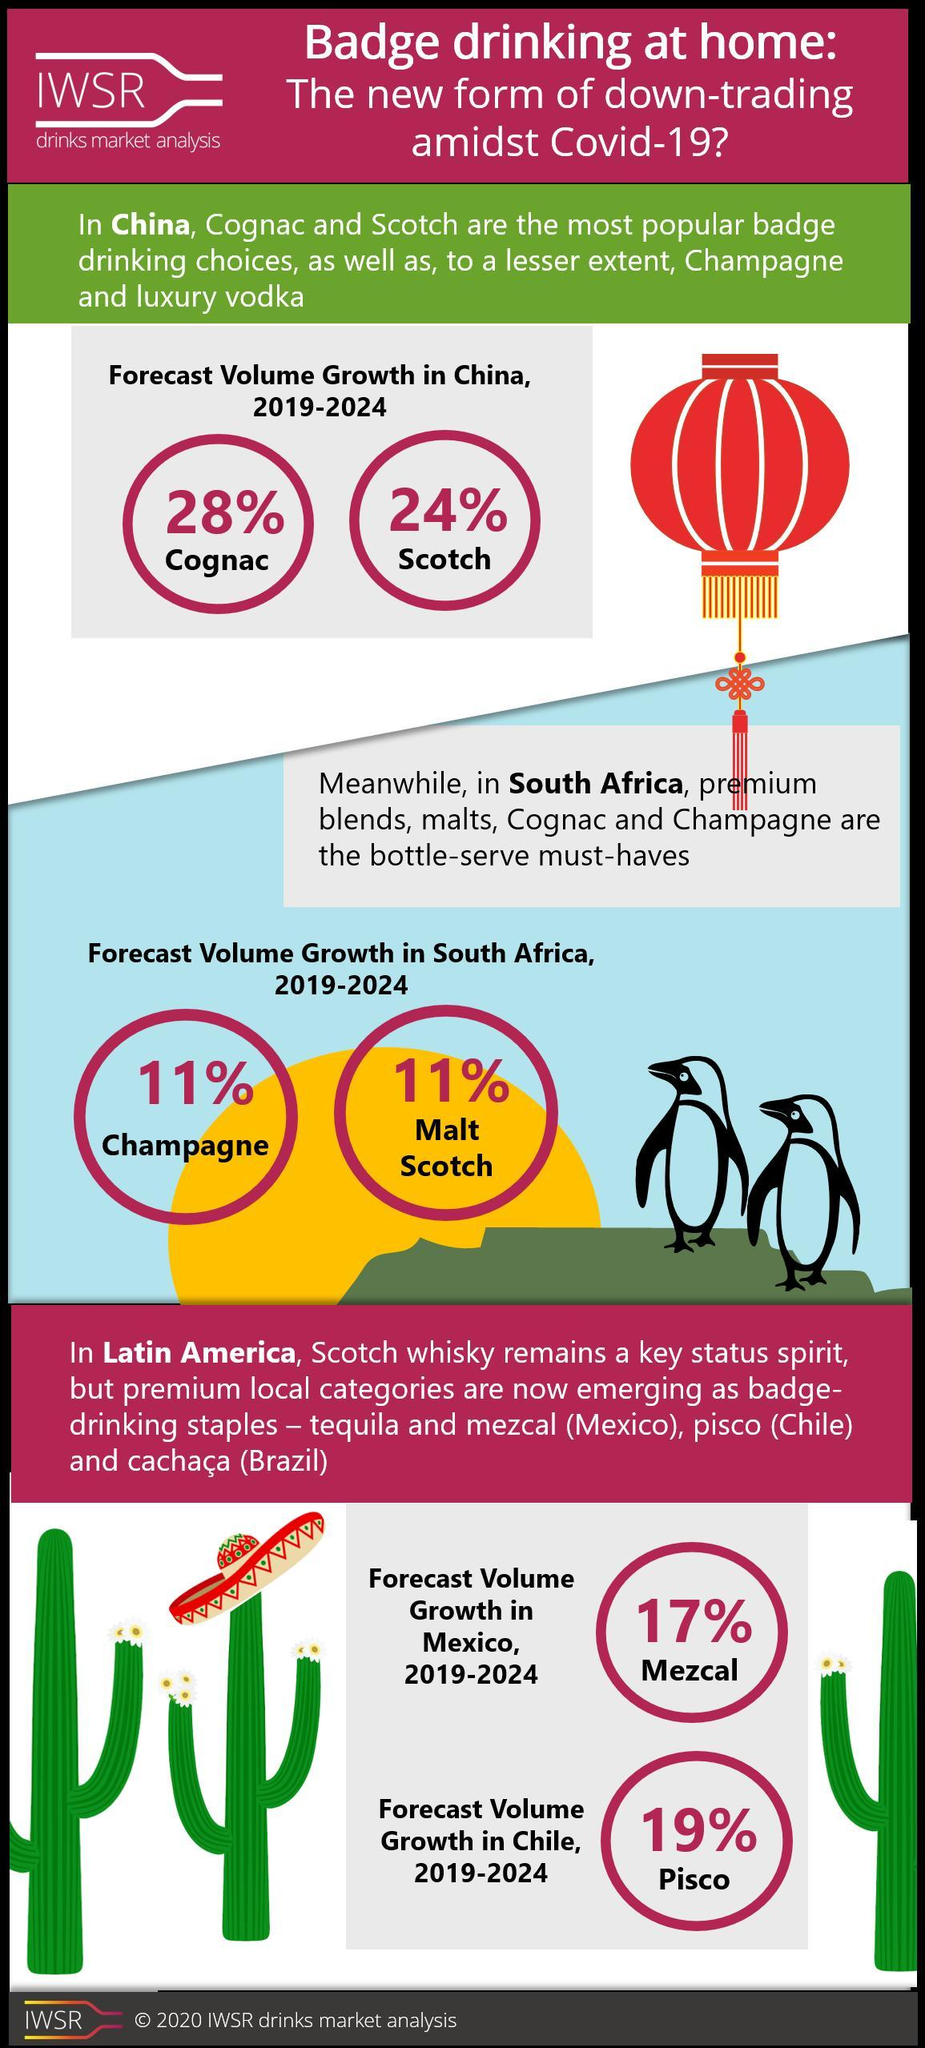What is the forecast volume growth of badge drinking of champagne in South Africa during 2019-2024?
Answer the question with a short phrase. 11% What is the forecast volume growth of badge drinking of scotch in China during 2019-2024? 24% What is the forecast volume growth of badge drinking of cognac in China during 2019-2024? 28% Which is the badge drinking staple in Mexico other than the mezcal during 2019-2024? tequila 